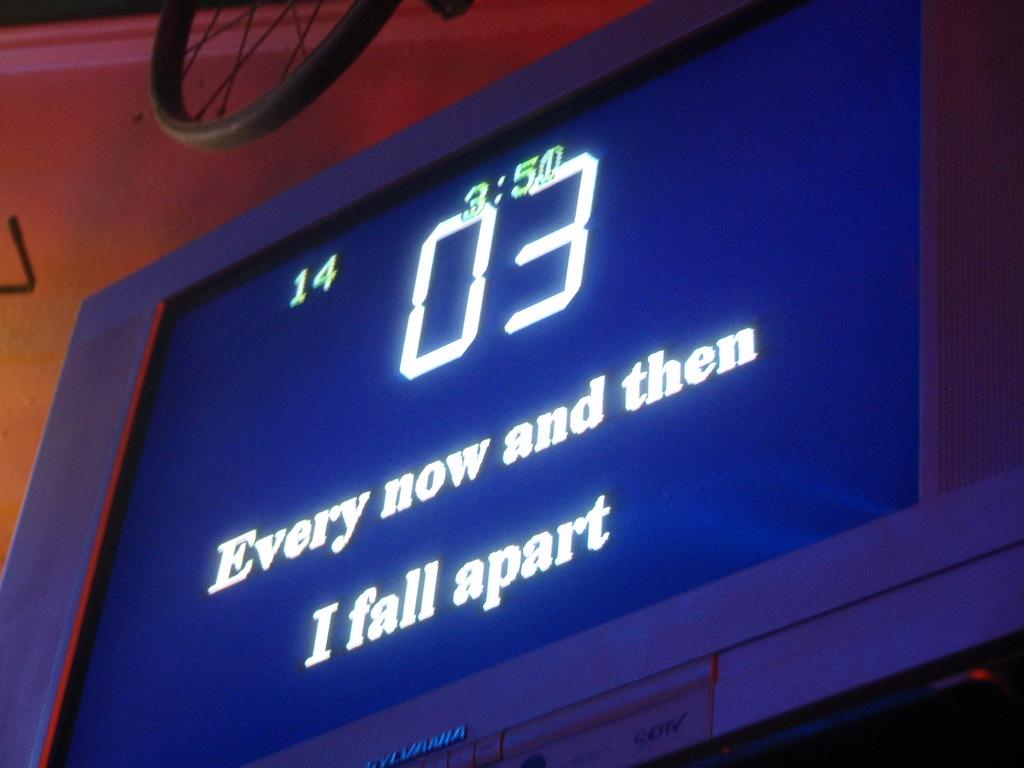Provide a one-sentence caption for the provided image. A Sylvania TV showing song lyrics "Every now and then I fall apart". 